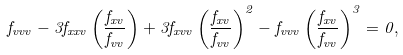Convert formula to latex. <formula><loc_0><loc_0><loc_500><loc_500>f _ { v v v } - 3 f _ { x x v } \left ( \frac { f _ { x v } } { f _ { v v } } \right ) + 3 f _ { x v v } \left ( \frac { f _ { x v } } { f _ { v v } } \right ) ^ { 2 } - f _ { v v v } \left ( \frac { f _ { x v } } { f _ { v v } } \right ) ^ { 3 } = 0 ,</formula> 